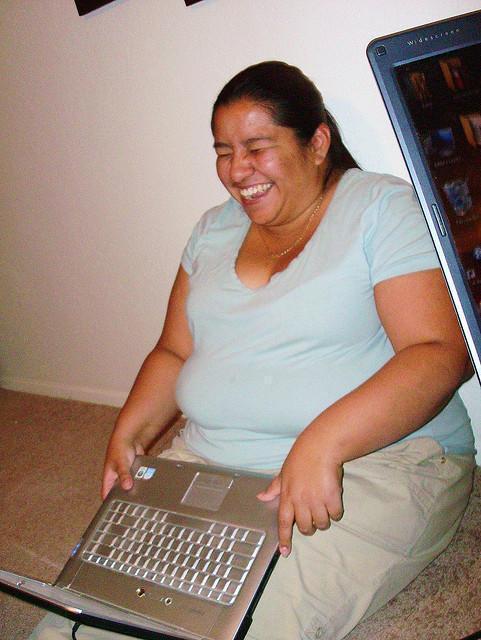What OS is the laptop on the right displaying on its screen?
From the following four choices, select the correct answer to address the question.
Options: Windows xp, macos, windows 10, windows vista. Windows vista. 